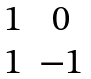Convert formula to latex. <formula><loc_0><loc_0><loc_500><loc_500>\begin{matrix} 1 & 0 \\ 1 & - 1 \end{matrix}</formula> 